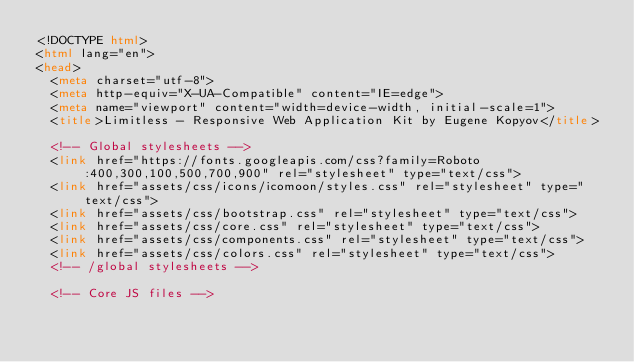<code> <loc_0><loc_0><loc_500><loc_500><_HTML_><!DOCTYPE html>
<html lang="en">
<head>
	<meta charset="utf-8">
	<meta http-equiv="X-UA-Compatible" content="IE=edge">
	<meta name="viewport" content="width=device-width, initial-scale=1">
	<title>Limitless - Responsive Web Application Kit by Eugene Kopyov</title>

	<!-- Global stylesheets -->
	<link href="https://fonts.googleapis.com/css?family=Roboto:400,300,100,500,700,900" rel="stylesheet" type="text/css">
	<link href="assets/css/icons/icomoon/styles.css" rel="stylesheet" type="text/css">
	<link href="assets/css/bootstrap.css" rel="stylesheet" type="text/css">
	<link href="assets/css/core.css" rel="stylesheet" type="text/css">
	<link href="assets/css/components.css" rel="stylesheet" type="text/css">
	<link href="assets/css/colors.css" rel="stylesheet" type="text/css">
	<!-- /global stylesheets -->

	<!-- Core JS files --></code> 